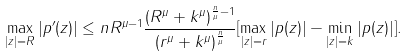<formula> <loc_0><loc_0><loc_500><loc_500>\max _ { | z | = R } | p ^ { \prime } ( z ) | \leq n R ^ { \mu - 1 } \frac { ( R ^ { \mu } + k ^ { \mu } ) ^ { \frac { n } { \mu } - 1 } } { ( r ^ { \mu } + k ^ { \mu } ) ^ { \frac { n } { \mu } } } [ \max _ { | z | = r } | p ( z ) | - \min _ { | z | = k } | p ( z ) | ] .</formula> 